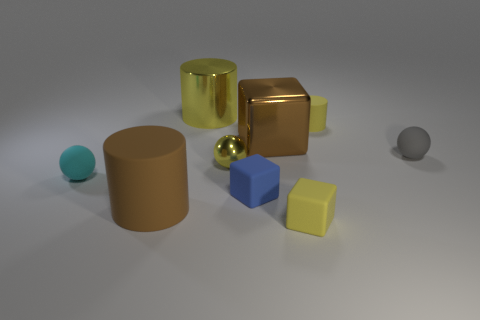Do the object behind the small cylinder and the yellow sphere have the same material?
Give a very brief answer. Yes. Are there any balls that are in front of the block that is to the left of the shiny block?
Keep it short and to the point. No. There is a brown object that is the same shape as the blue rubber object; what is its material?
Keep it short and to the point. Metal. Is the number of large matte cylinders that are on the right side of the blue cube greater than the number of metallic things in front of the tiny cyan object?
Give a very brief answer. No. There is a big object that is made of the same material as the big block; what is its shape?
Offer a very short reply. Cylinder. Is the number of big brown things that are to the left of the brown shiny block greater than the number of blue objects?
Keep it short and to the point. No. What number of cylinders are the same color as the small metal ball?
Your response must be concise. 2. How many other objects are the same color as the big rubber cylinder?
Your answer should be compact. 1. Is the number of objects greater than the number of small purple shiny things?
Ensure brevity in your answer.  Yes. What material is the cyan ball?
Make the answer very short. Rubber. 